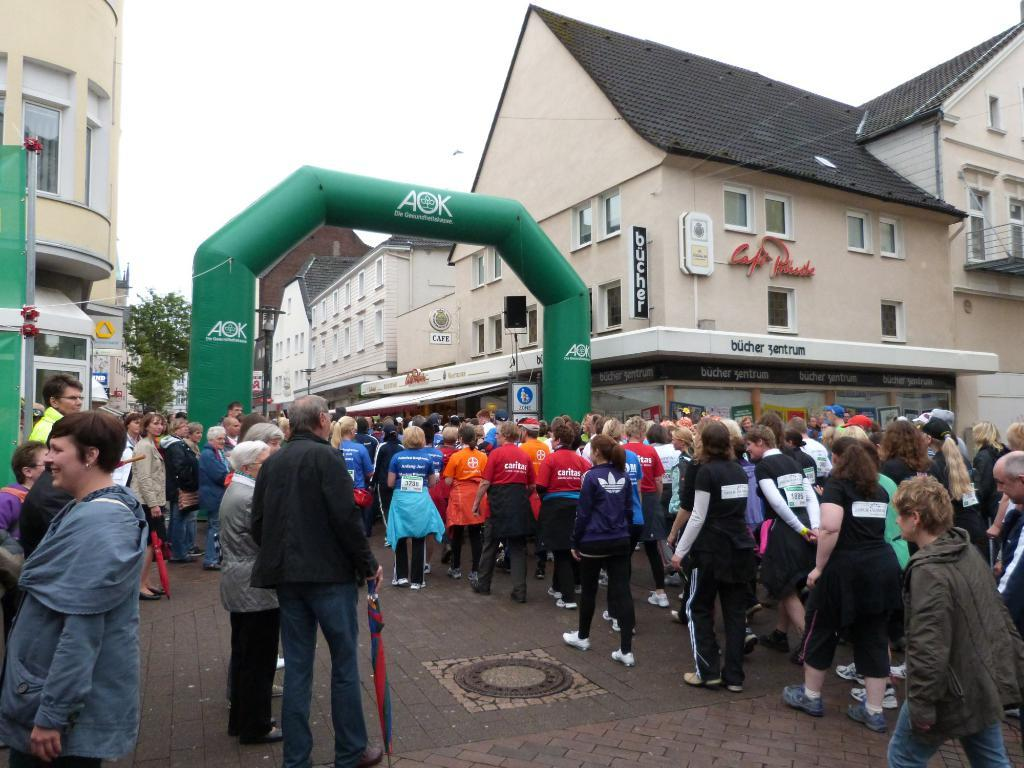What is the main object in the image? There is a manhole in the image. What else can be seen in the image besides the manhole? There is a group of people on the ground in the image. What can be seen in the background of the image? There are buildings, trees, and the sky visible in the background of the image. Can you describe the unspecified objects in the background? Unfortunately, the provided facts do not specify the nature of the unspecified objects in the background. What type of bear can be seen with sharp fangs in the image? There is no bear or fangs present in the image; it features a manhole and a group of people on the ground. 